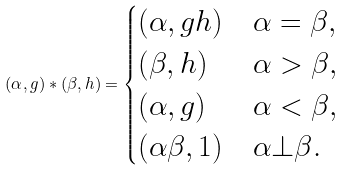Convert formula to latex. <formula><loc_0><loc_0><loc_500><loc_500>( \alpha , g ) * ( \beta , h ) = \begin{cases} ( \alpha , g h ) & \alpha = \beta , \\ ( \beta , h ) & \alpha > \beta , \\ ( \alpha , g ) & \alpha < \beta , \\ ( \alpha \beta , 1 ) & \alpha \bot \beta . \end{cases}</formula> 